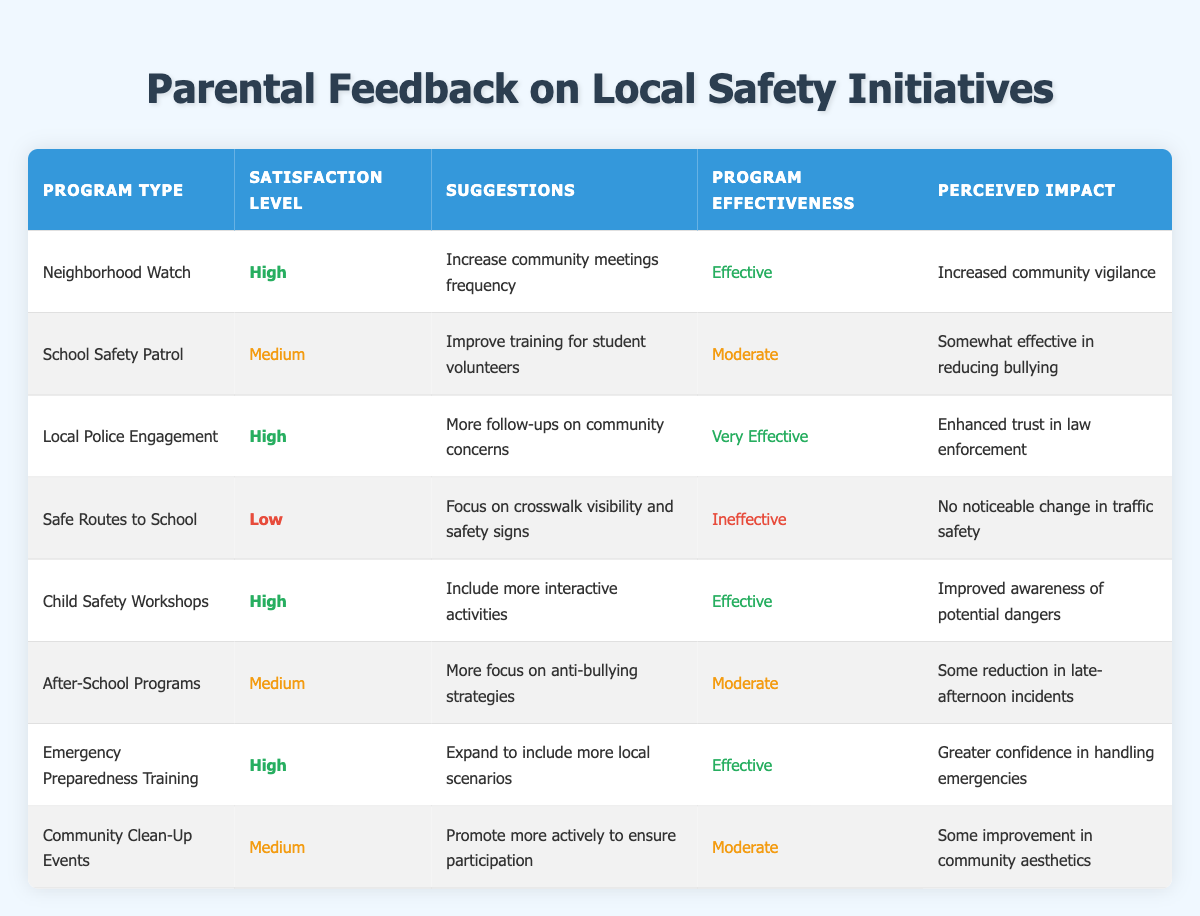What is the satisfaction level for the Safe Routes to School program? The table shows that the satisfaction level for the Safe Routes to School program is marked as Low.
Answer: Low What suggestions were made for the School Safety Patrol program? According to the table, the suggestions for the School Safety Patrol program are to improve training for student volunteers.
Answer: Improve training for student volunteers How many programs have a satisfaction level categorized as High? By counting the rows in the table, the Neighborhood Watch, Local Police Engagement, Child Safety Workshops, and Emergency Preparedness Training programs each have a satisfaction level categorized as High. This totals 4 programs.
Answer: 4 Is the perceived impact of the Child Safety Workshops positive? The perceived impact listed for the Child Safety Workshops is improved awareness of potential dangers, which indicates a positive effect.
Answer: Yes What is the difference between the number of effective programs and ineffective programs? There are 5 effective programs: Neighborhood Watch, Local Police Engagement, Child Safety Workshops, Emergency Preparedness Training, and School Safety Patrol (considered moderate but effective). There is 1 ineffective program, which is Safe Routes to School. Therefore, the difference is 5 - 1 = 4.
Answer: 4 Which program received the suggestion to focus on crosswalk visibility and safety signs? The table states that the Safe Routes to School program received the suggestion to focus on crosswalk visibility and safety signs.
Answer: Safe Routes to School What is the average satisfaction level of programs categorized as Medium? The satisfaction levels for the Medium programs are School Safety Patrol, After-School Programs, and Community Clean-Up Events. There are three programs, so to assign numerical values: High = 3, Medium = 2, Low = 1. Thus, the average satisfaction level for Medium is (2 + 2 + 2) / 3 = 2.
Answer: 2 Do any programs have a perceived impact regarding community aesthetics? The table indicates that the Community Clean-Up Events program has a perceived impact of some improvement in community aesthetics, confirming that there is indeed a program with that focus.
Answer: Yes Which program mentions enhanced trust in law enforcement as a perceived impact? The perceived impact of the Local Police Engagement program is noted as enhanced trust in law enforcement.
Answer: Local Police Engagement 